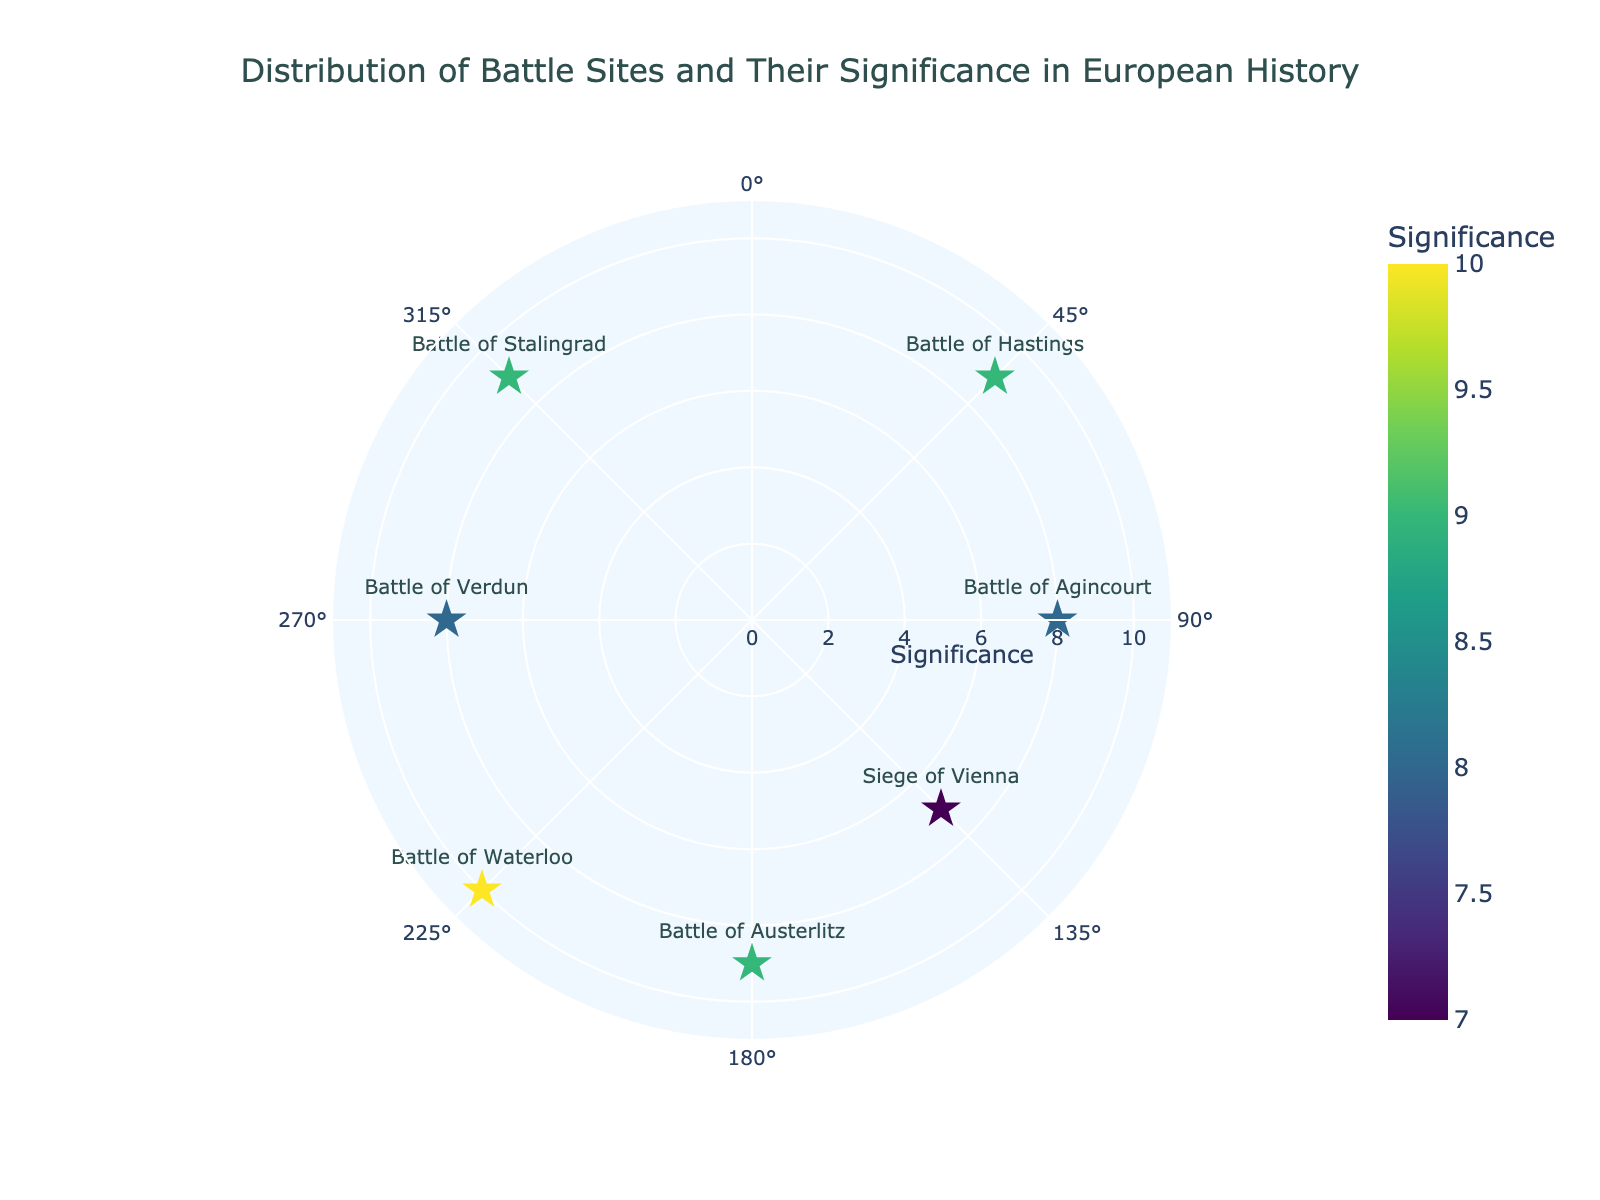What is the title of the figure? The title is located at the top center of the figure and generally provides a concise summary of the visualization. In this case, it reads 'Distribution of Battle Sites and Their Significance in European History.'
Answer: Distribution of Battle Sites and Their Significance in European History How many battle sites are represented in the figure? By examining the number of markers (stars) on the chart, we can count that there are 7 distinct battle sites represented.
Answer: 7 Which battle site has the highest significance? Look at the color scale and the radius axis (Significance). The Battle of Waterloo is placed at 225 degrees with a radius of 10, making it the highest significance.
Answer: Battle of Waterloo What is the average significance of the battle sites? First, sum up all the significance values: 9 + 8 + 7 + 9 + 10 + 8 + 9 = 60. Then, divide by the number of battle sites, which is 7. So, the average is 60 / 7 ≈ 8.57.
Answer: 8.57 Which battle sites have a significance of 9? Look at the markers and their significance values. The Battle of Hastings, Battle of Austerlitz, and Battle of Stalingrad each have a significance of 9.
Answer: Battle of Hastings, Battle of Austerlitz, Battle of Stalingrad Where is the Battle of Agincourt placed in terms of theta (degrees)? Check the theta (angular) axis labels and find the point corresponding to the Battle of Agincourt, which is marked at 90 degrees.
Answer: 90 degrees How does the significance of the Battle of Verdun compare to the Battle of Agincourt? The Battle of Verdun has a significance of 8, while the Battle of Agincourt also has a significance of 8. Therefore, they are equal in significance.
Answer: Equal Are there more battle sites with significance greater than or equal to 8 or less than 8? Count the markers by significance: greater than or equal to 8 includes Battle of Hastings (9), Battle of Agincourt (8), Battle of Austerlitz (9), Battle of Waterloo (10), Battle of Verdun (8), Battle of Stalingrad (9). Less than 8 includes only Siege of Vienna (7). Thus, more have significance greater than or equal to 8.
Answer: Greater than or equal to 8 What is the range of significance values in the chart? The minimum significance value is 7 (Siege of Vienna), and the maximum is 10 (Battle of Waterloo). Subtracting these gives us the range: 10 - 7 = 3.
Answer: 3 